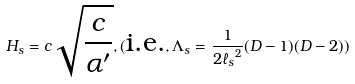Convert formula to latex. <formula><loc_0><loc_0><loc_500><loc_500>H _ { s } = c \sqrt { \frac { c } { \alpha ^ { \prime } } } , ( \text {i.e.} , \Lambda _ { s } = \frac { 1 } { 2 { \ell _ { s } } ^ { 2 } } ( D - 1 ) ( D - 2 ) )</formula> 